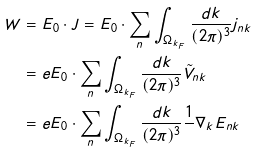Convert formula to latex. <formula><loc_0><loc_0><loc_500><loc_500>W & = E _ { 0 } \cdot J = E _ { 0 } \cdot \sum _ { n } \int _ { \Omega _ { k _ { F } } } \frac { d k } { ( 2 \pi ) ^ { 3 } } j _ { n k } \\ & = e E _ { 0 } \cdot \sum _ { n } \int _ { \Omega _ { k _ { F } } } \frac { d k } { ( 2 \pi ) ^ { 3 } } \tilde { V } _ { n k } \\ & = e E _ { 0 } \cdot \sum _ { n } \int _ { \Omega _ { k _ { F } } } \frac { d k } { ( 2 \pi ) ^ { 3 } } \frac { 1 } { } \nabla _ { k } E _ { n k } \\</formula> 